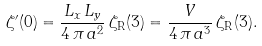<formula> <loc_0><loc_0><loc_500><loc_500>\zeta ^ { \prime } ( 0 ) = \frac { L _ { x } \, L _ { y } } { 4 \, \pi \, a ^ { 2 } } \, \zeta _ { \text {R} } ( 3 ) = \frac { V } { 4 \, \pi \, a ^ { 3 } } \, \zeta _ { \text {R} } ( 3 ) .</formula> 